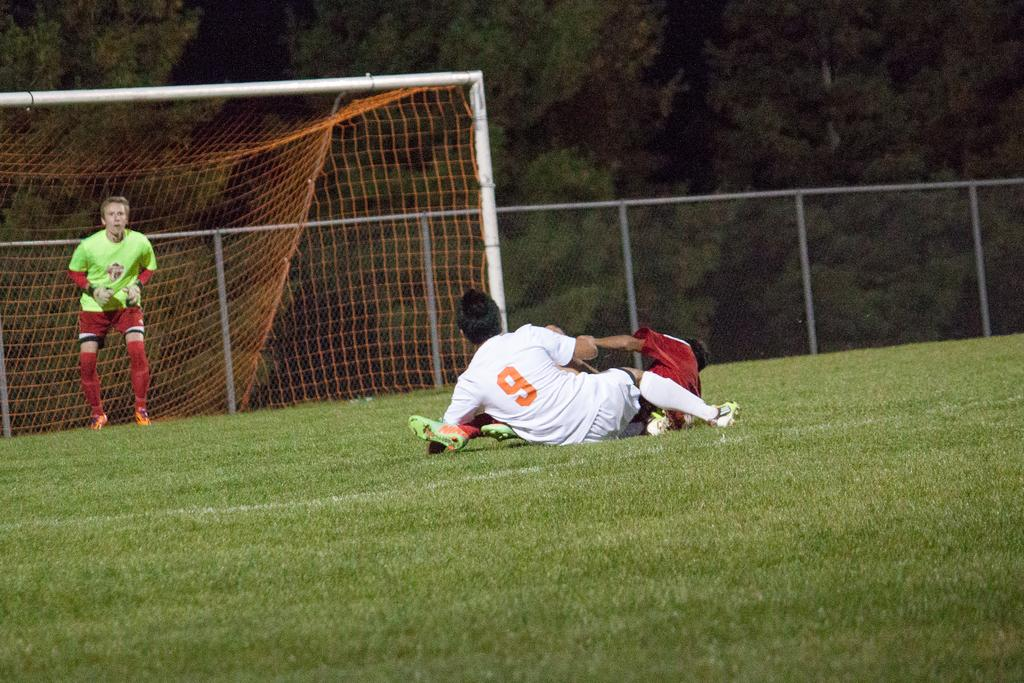<image>
Summarize the visual content of the image. A person in a number 9 jersey is playing soccer and has fallen to the ground. 